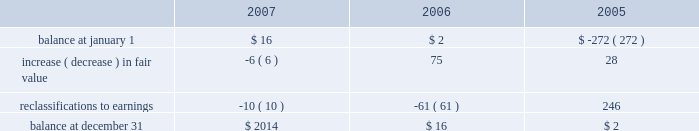The fair value of the interest agreements at december 31 , 2007 and december 31 , 2006 was $ 3 million and $ 1 million , respectively .
The company is exposed to credit loss in the event of nonperformance by the counterparties to its swap contracts .
The company minimizes its credit risk on these transactions by only dealing with leading , creditworthy financial institutions and does not anticipate nonperformance .
In addition , the contracts are distributed among several financial institutions , all of whom presently have investment grade credit ratings , thus minimizing credit risk concentration .
Stockholders 2019 equity derivative instruments activity , net of tax , included in non-owner changes to equity within the consolidated statements of stockholders 2019 equity for the years ended december 31 , 2007 and 2006 is as follows: .
Net investment in foreign operations hedge at december 31 , 2007 and 2006 , the company did not have any hedges of foreign currency exposure of net investments in foreign operations .
Investments hedge during the first quarter of 2006 , the company entered into a zero-cost collar derivative ( the 201csprint nextel derivative 201d ) to protect itself economically against price fluctuations in its 37.6 million shares of sprint nextel corporation ( 201csprint nextel 201d ) non-voting common stock .
During the second quarter of 2006 , as a result of sprint nextel 2019s spin-off of embarq corporation through a dividend to sprint nextel shareholders , the company received approximately 1.9 million shares of embarq corporation .
The floor and ceiling prices of the sprint nextel derivative were adjusted accordingly .
The sprint nextel derivative was not designated as a hedge under the provisions of sfas no .
133 , 201caccounting for derivative instruments and hedging activities . 201d accordingly , to reflect the change in fair value of the sprint nextel derivative , the company recorded a net gain of $ 99 million for the year ended december 31 , 2006 , included in other income ( expense ) in the company 2019s consolidated statements of operations .
In december 2006 , the sprint nextel derivative was terminated and settled in cash and the 37.6 million shares of sprint nextel were converted to common shares and sold .
The company received aggregate cash proceeds of approximately $ 820 million from the settlement of the sprint nextel derivative and the subsequent sale of the 37.6 million sprint nextel shares .
The company recognized a loss of $ 126 million in connection with the sale of the remaining shares of sprint nextel common stock .
As described above , the company recorded a net gain of $ 99 million in connection with the sprint nextel derivative .
Prior to the merger of sprint corporation ( 201csprint 201d ) and nextel communications , inc .
( 201cnextel 201d ) , the company had entered into variable share forward purchase agreements ( the 201cvariable forwards 201d ) to hedge its nextel common stock .
The company did not designate the variable forwards as a hedge of the sprint nextel shares received as a result of the merger .
Accordingly , the company recorded $ 51 million of gains for the year ended december 31 , 2005 reflecting the change in value of the variable forwards .
The variable forwards were settled during the fourth quarter of 2005 .
Fair value of financial instruments the company 2019s financial instruments include cash equivalents , sigma fund investments , short-term investments , accounts receivable , long-term finance receivables , accounts payable , accrued liabilities , derivatives and other financing commitments .
The company 2019s sigma fund and investment portfolios and derivatives are recorded in the company 2019s consolidated balance sheets at fair value .
All other financial instruments , with the exception of long-term debt , are carried at cost , which is not materially different than the instruments 2019 fair values. .
What was the fair value of the interest agreements at december 31 , 2007 to 2006? 
Computations: (3 / 1)
Answer: 3.0. 